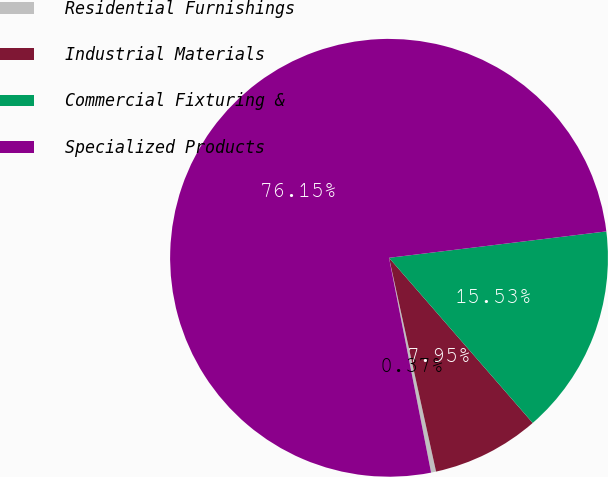Convert chart. <chart><loc_0><loc_0><loc_500><loc_500><pie_chart><fcel>Residential Furnishings<fcel>Industrial Materials<fcel>Commercial Fixturing &<fcel>Specialized Products<nl><fcel>0.37%<fcel>7.95%<fcel>15.53%<fcel>76.16%<nl></chart> 